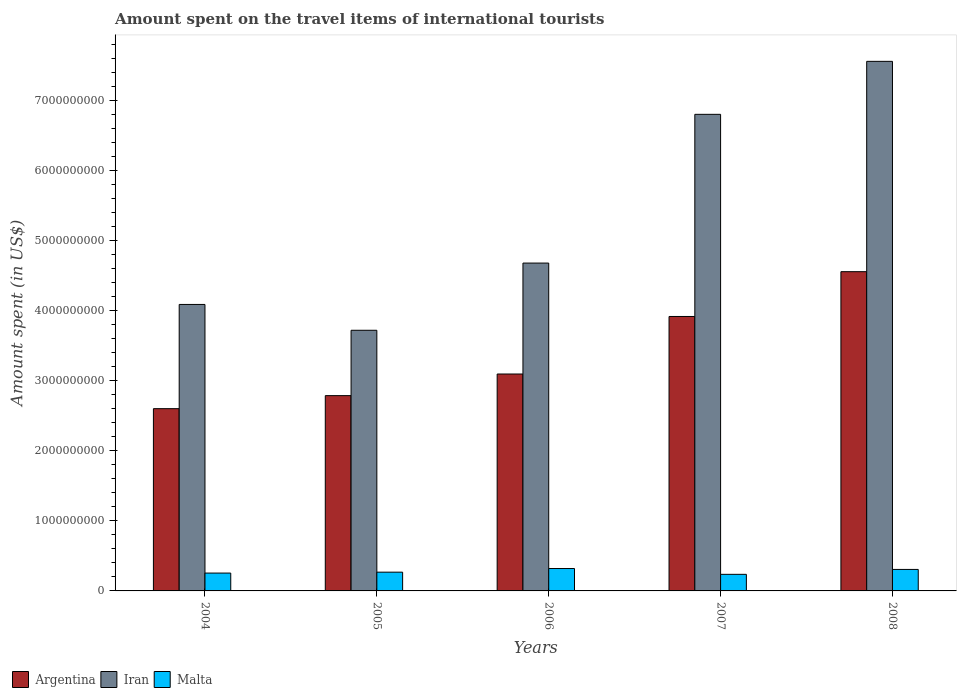Are the number of bars per tick equal to the number of legend labels?
Your answer should be very brief. Yes. How many bars are there on the 1st tick from the left?
Ensure brevity in your answer.  3. How many bars are there on the 2nd tick from the right?
Provide a succinct answer. 3. In how many cases, is the number of bars for a given year not equal to the number of legend labels?
Keep it short and to the point. 0. What is the amount spent on the travel items of international tourists in Argentina in 2005?
Make the answer very short. 2.79e+09. Across all years, what is the maximum amount spent on the travel items of international tourists in Iran?
Your answer should be compact. 7.57e+09. Across all years, what is the minimum amount spent on the travel items of international tourists in Malta?
Give a very brief answer. 2.37e+08. What is the total amount spent on the travel items of international tourists in Malta in the graph?
Your answer should be compact. 1.39e+09. What is the difference between the amount spent on the travel items of international tourists in Malta in 2005 and that in 2006?
Provide a succinct answer. -5.20e+07. What is the difference between the amount spent on the travel items of international tourists in Argentina in 2005 and the amount spent on the travel items of international tourists in Iran in 2006?
Offer a terse response. -1.89e+09. What is the average amount spent on the travel items of international tourists in Malta per year?
Your response must be concise. 2.77e+08. In the year 2005, what is the difference between the amount spent on the travel items of international tourists in Iran and amount spent on the travel items of international tourists in Argentina?
Your answer should be very brief. 9.34e+08. What is the ratio of the amount spent on the travel items of international tourists in Argentina in 2005 to that in 2008?
Give a very brief answer. 0.61. Is the difference between the amount spent on the travel items of international tourists in Iran in 2006 and 2007 greater than the difference between the amount spent on the travel items of international tourists in Argentina in 2006 and 2007?
Offer a very short reply. No. What is the difference between the highest and the second highest amount spent on the travel items of international tourists in Argentina?
Give a very brief answer. 6.40e+08. What is the difference between the highest and the lowest amount spent on the travel items of international tourists in Argentina?
Make the answer very short. 1.96e+09. Is the sum of the amount spent on the travel items of international tourists in Iran in 2007 and 2008 greater than the maximum amount spent on the travel items of international tourists in Malta across all years?
Make the answer very short. Yes. What does the 2nd bar from the left in 2004 represents?
Offer a terse response. Iran. What does the 3rd bar from the right in 2008 represents?
Your answer should be compact. Argentina. How many bars are there?
Your response must be concise. 15. Are all the bars in the graph horizontal?
Your answer should be very brief. No. What is the difference between two consecutive major ticks on the Y-axis?
Your response must be concise. 1.00e+09. Are the values on the major ticks of Y-axis written in scientific E-notation?
Keep it short and to the point. No. Does the graph contain any zero values?
Ensure brevity in your answer.  No. Does the graph contain grids?
Your answer should be very brief. No. How many legend labels are there?
Your response must be concise. 3. How are the legend labels stacked?
Your answer should be very brief. Horizontal. What is the title of the graph?
Offer a terse response. Amount spent on the travel items of international tourists. Does "Syrian Arab Republic" appear as one of the legend labels in the graph?
Offer a terse response. No. What is the label or title of the Y-axis?
Your answer should be very brief. Amount spent (in US$). What is the Amount spent (in US$) of Argentina in 2004?
Provide a succinct answer. 2.60e+09. What is the Amount spent (in US$) of Iran in 2004?
Provide a succinct answer. 4.09e+09. What is the Amount spent (in US$) of Malta in 2004?
Make the answer very short. 2.55e+08. What is the Amount spent (in US$) in Argentina in 2005?
Offer a very short reply. 2.79e+09. What is the Amount spent (in US$) in Iran in 2005?
Provide a succinct answer. 3.72e+09. What is the Amount spent (in US$) in Malta in 2005?
Your response must be concise. 2.68e+08. What is the Amount spent (in US$) of Argentina in 2006?
Give a very brief answer. 3.10e+09. What is the Amount spent (in US$) in Iran in 2006?
Provide a short and direct response. 4.68e+09. What is the Amount spent (in US$) in Malta in 2006?
Give a very brief answer. 3.20e+08. What is the Amount spent (in US$) in Argentina in 2007?
Your response must be concise. 3.92e+09. What is the Amount spent (in US$) of Iran in 2007?
Give a very brief answer. 6.81e+09. What is the Amount spent (in US$) in Malta in 2007?
Provide a short and direct response. 2.37e+08. What is the Amount spent (in US$) of Argentina in 2008?
Your answer should be very brief. 4.56e+09. What is the Amount spent (in US$) in Iran in 2008?
Provide a succinct answer. 7.57e+09. What is the Amount spent (in US$) of Malta in 2008?
Offer a terse response. 3.07e+08. Across all years, what is the maximum Amount spent (in US$) in Argentina?
Give a very brief answer. 4.56e+09. Across all years, what is the maximum Amount spent (in US$) in Iran?
Keep it short and to the point. 7.57e+09. Across all years, what is the maximum Amount spent (in US$) in Malta?
Give a very brief answer. 3.20e+08. Across all years, what is the minimum Amount spent (in US$) in Argentina?
Keep it short and to the point. 2.60e+09. Across all years, what is the minimum Amount spent (in US$) in Iran?
Provide a short and direct response. 3.72e+09. Across all years, what is the minimum Amount spent (in US$) of Malta?
Offer a terse response. 2.37e+08. What is the total Amount spent (in US$) in Argentina in the graph?
Your response must be concise. 1.70e+1. What is the total Amount spent (in US$) of Iran in the graph?
Make the answer very short. 2.69e+1. What is the total Amount spent (in US$) in Malta in the graph?
Offer a very short reply. 1.39e+09. What is the difference between the Amount spent (in US$) in Argentina in 2004 and that in 2005?
Provide a succinct answer. -1.86e+08. What is the difference between the Amount spent (in US$) of Iran in 2004 and that in 2005?
Your answer should be very brief. 3.69e+08. What is the difference between the Amount spent (in US$) of Malta in 2004 and that in 2005?
Your response must be concise. -1.30e+07. What is the difference between the Amount spent (in US$) in Argentina in 2004 and that in 2006?
Provide a succinct answer. -4.95e+08. What is the difference between the Amount spent (in US$) in Iran in 2004 and that in 2006?
Provide a succinct answer. -5.91e+08. What is the difference between the Amount spent (in US$) of Malta in 2004 and that in 2006?
Give a very brief answer. -6.50e+07. What is the difference between the Amount spent (in US$) of Argentina in 2004 and that in 2007?
Give a very brief answer. -1.32e+09. What is the difference between the Amount spent (in US$) in Iran in 2004 and that in 2007?
Your answer should be compact. -2.72e+09. What is the difference between the Amount spent (in US$) in Malta in 2004 and that in 2007?
Make the answer very short. 1.80e+07. What is the difference between the Amount spent (in US$) of Argentina in 2004 and that in 2008?
Your answer should be compact. -1.96e+09. What is the difference between the Amount spent (in US$) in Iran in 2004 and that in 2008?
Offer a terse response. -3.47e+09. What is the difference between the Amount spent (in US$) in Malta in 2004 and that in 2008?
Your answer should be very brief. -5.20e+07. What is the difference between the Amount spent (in US$) in Argentina in 2005 and that in 2006?
Offer a terse response. -3.09e+08. What is the difference between the Amount spent (in US$) of Iran in 2005 and that in 2006?
Your response must be concise. -9.60e+08. What is the difference between the Amount spent (in US$) of Malta in 2005 and that in 2006?
Offer a very short reply. -5.20e+07. What is the difference between the Amount spent (in US$) in Argentina in 2005 and that in 2007?
Ensure brevity in your answer.  -1.13e+09. What is the difference between the Amount spent (in US$) in Iran in 2005 and that in 2007?
Offer a terse response. -3.08e+09. What is the difference between the Amount spent (in US$) in Malta in 2005 and that in 2007?
Keep it short and to the point. 3.10e+07. What is the difference between the Amount spent (in US$) of Argentina in 2005 and that in 2008?
Provide a succinct answer. -1.77e+09. What is the difference between the Amount spent (in US$) of Iran in 2005 and that in 2008?
Provide a succinct answer. -3.84e+09. What is the difference between the Amount spent (in US$) in Malta in 2005 and that in 2008?
Provide a succinct answer. -3.90e+07. What is the difference between the Amount spent (in US$) in Argentina in 2006 and that in 2007?
Give a very brief answer. -8.22e+08. What is the difference between the Amount spent (in US$) in Iran in 2006 and that in 2007?
Offer a terse response. -2.12e+09. What is the difference between the Amount spent (in US$) in Malta in 2006 and that in 2007?
Your response must be concise. 8.30e+07. What is the difference between the Amount spent (in US$) of Argentina in 2006 and that in 2008?
Provide a succinct answer. -1.46e+09. What is the difference between the Amount spent (in US$) in Iran in 2006 and that in 2008?
Provide a succinct answer. -2.88e+09. What is the difference between the Amount spent (in US$) of Malta in 2006 and that in 2008?
Your response must be concise. 1.30e+07. What is the difference between the Amount spent (in US$) in Argentina in 2007 and that in 2008?
Offer a very short reply. -6.40e+08. What is the difference between the Amount spent (in US$) in Iran in 2007 and that in 2008?
Ensure brevity in your answer.  -7.57e+08. What is the difference between the Amount spent (in US$) in Malta in 2007 and that in 2008?
Your answer should be very brief. -7.00e+07. What is the difference between the Amount spent (in US$) in Argentina in 2004 and the Amount spent (in US$) in Iran in 2005?
Make the answer very short. -1.12e+09. What is the difference between the Amount spent (in US$) of Argentina in 2004 and the Amount spent (in US$) of Malta in 2005?
Provide a short and direct response. 2.34e+09. What is the difference between the Amount spent (in US$) of Iran in 2004 and the Amount spent (in US$) of Malta in 2005?
Your answer should be compact. 3.82e+09. What is the difference between the Amount spent (in US$) of Argentina in 2004 and the Amount spent (in US$) of Iran in 2006?
Your answer should be very brief. -2.08e+09. What is the difference between the Amount spent (in US$) in Argentina in 2004 and the Amount spent (in US$) in Malta in 2006?
Offer a very short reply. 2.28e+09. What is the difference between the Amount spent (in US$) of Iran in 2004 and the Amount spent (in US$) of Malta in 2006?
Give a very brief answer. 3.77e+09. What is the difference between the Amount spent (in US$) in Argentina in 2004 and the Amount spent (in US$) in Iran in 2007?
Provide a succinct answer. -4.20e+09. What is the difference between the Amount spent (in US$) in Argentina in 2004 and the Amount spent (in US$) in Malta in 2007?
Give a very brief answer. 2.37e+09. What is the difference between the Amount spent (in US$) in Iran in 2004 and the Amount spent (in US$) in Malta in 2007?
Your response must be concise. 3.86e+09. What is the difference between the Amount spent (in US$) of Argentina in 2004 and the Amount spent (in US$) of Iran in 2008?
Give a very brief answer. -4.96e+09. What is the difference between the Amount spent (in US$) in Argentina in 2004 and the Amount spent (in US$) in Malta in 2008?
Make the answer very short. 2.30e+09. What is the difference between the Amount spent (in US$) of Iran in 2004 and the Amount spent (in US$) of Malta in 2008?
Make the answer very short. 3.79e+09. What is the difference between the Amount spent (in US$) in Argentina in 2005 and the Amount spent (in US$) in Iran in 2006?
Ensure brevity in your answer.  -1.89e+09. What is the difference between the Amount spent (in US$) in Argentina in 2005 and the Amount spent (in US$) in Malta in 2006?
Your answer should be compact. 2.47e+09. What is the difference between the Amount spent (in US$) of Iran in 2005 and the Amount spent (in US$) of Malta in 2006?
Ensure brevity in your answer.  3.40e+09. What is the difference between the Amount spent (in US$) in Argentina in 2005 and the Amount spent (in US$) in Iran in 2007?
Offer a very short reply. -4.02e+09. What is the difference between the Amount spent (in US$) in Argentina in 2005 and the Amount spent (in US$) in Malta in 2007?
Give a very brief answer. 2.55e+09. What is the difference between the Amount spent (in US$) in Iran in 2005 and the Amount spent (in US$) in Malta in 2007?
Provide a short and direct response. 3.49e+09. What is the difference between the Amount spent (in US$) of Argentina in 2005 and the Amount spent (in US$) of Iran in 2008?
Your answer should be compact. -4.78e+09. What is the difference between the Amount spent (in US$) in Argentina in 2005 and the Amount spent (in US$) in Malta in 2008?
Make the answer very short. 2.48e+09. What is the difference between the Amount spent (in US$) of Iran in 2005 and the Amount spent (in US$) of Malta in 2008?
Provide a succinct answer. 3.42e+09. What is the difference between the Amount spent (in US$) of Argentina in 2006 and the Amount spent (in US$) of Iran in 2007?
Your response must be concise. -3.71e+09. What is the difference between the Amount spent (in US$) of Argentina in 2006 and the Amount spent (in US$) of Malta in 2007?
Provide a short and direct response. 2.86e+09. What is the difference between the Amount spent (in US$) in Iran in 2006 and the Amount spent (in US$) in Malta in 2007?
Your answer should be very brief. 4.45e+09. What is the difference between the Amount spent (in US$) of Argentina in 2006 and the Amount spent (in US$) of Iran in 2008?
Ensure brevity in your answer.  -4.47e+09. What is the difference between the Amount spent (in US$) in Argentina in 2006 and the Amount spent (in US$) in Malta in 2008?
Provide a short and direct response. 2.79e+09. What is the difference between the Amount spent (in US$) of Iran in 2006 and the Amount spent (in US$) of Malta in 2008?
Give a very brief answer. 4.38e+09. What is the difference between the Amount spent (in US$) of Argentina in 2007 and the Amount spent (in US$) of Iran in 2008?
Make the answer very short. -3.64e+09. What is the difference between the Amount spent (in US$) in Argentina in 2007 and the Amount spent (in US$) in Malta in 2008?
Provide a short and direct response. 3.61e+09. What is the difference between the Amount spent (in US$) of Iran in 2007 and the Amount spent (in US$) of Malta in 2008?
Make the answer very short. 6.50e+09. What is the average Amount spent (in US$) in Argentina per year?
Keep it short and to the point. 3.40e+09. What is the average Amount spent (in US$) in Iran per year?
Your response must be concise. 5.38e+09. What is the average Amount spent (in US$) of Malta per year?
Make the answer very short. 2.77e+08. In the year 2004, what is the difference between the Amount spent (in US$) in Argentina and Amount spent (in US$) in Iran?
Make the answer very short. -1.49e+09. In the year 2004, what is the difference between the Amount spent (in US$) of Argentina and Amount spent (in US$) of Malta?
Your answer should be compact. 2.35e+09. In the year 2004, what is the difference between the Amount spent (in US$) in Iran and Amount spent (in US$) in Malta?
Your answer should be compact. 3.84e+09. In the year 2005, what is the difference between the Amount spent (in US$) of Argentina and Amount spent (in US$) of Iran?
Offer a terse response. -9.34e+08. In the year 2005, what is the difference between the Amount spent (in US$) of Argentina and Amount spent (in US$) of Malta?
Make the answer very short. 2.52e+09. In the year 2005, what is the difference between the Amount spent (in US$) of Iran and Amount spent (in US$) of Malta?
Keep it short and to the point. 3.46e+09. In the year 2006, what is the difference between the Amount spent (in US$) in Argentina and Amount spent (in US$) in Iran?
Keep it short and to the point. -1.58e+09. In the year 2006, what is the difference between the Amount spent (in US$) of Argentina and Amount spent (in US$) of Malta?
Provide a short and direct response. 2.78e+09. In the year 2006, what is the difference between the Amount spent (in US$) of Iran and Amount spent (in US$) of Malta?
Ensure brevity in your answer.  4.36e+09. In the year 2007, what is the difference between the Amount spent (in US$) of Argentina and Amount spent (in US$) of Iran?
Offer a terse response. -2.89e+09. In the year 2007, what is the difference between the Amount spent (in US$) of Argentina and Amount spent (in US$) of Malta?
Provide a short and direct response. 3.68e+09. In the year 2007, what is the difference between the Amount spent (in US$) of Iran and Amount spent (in US$) of Malta?
Provide a succinct answer. 6.57e+09. In the year 2008, what is the difference between the Amount spent (in US$) in Argentina and Amount spent (in US$) in Iran?
Give a very brief answer. -3.00e+09. In the year 2008, what is the difference between the Amount spent (in US$) of Argentina and Amount spent (in US$) of Malta?
Ensure brevity in your answer.  4.25e+09. In the year 2008, what is the difference between the Amount spent (in US$) of Iran and Amount spent (in US$) of Malta?
Keep it short and to the point. 7.26e+09. What is the ratio of the Amount spent (in US$) of Argentina in 2004 to that in 2005?
Make the answer very short. 0.93. What is the ratio of the Amount spent (in US$) of Iran in 2004 to that in 2005?
Your answer should be very brief. 1.1. What is the ratio of the Amount spent (in US$) of Malta in 2004 to that in 2005?
Ensure brevity in your answer.  0.95. What is the ratio of the Amount spent (in US$) in Argentina in 2004 to that in 2006?
Ensure brevity in your answer.  0.84. What is the ratio of the Amount spent (in US$) of Iran in 2004 to that in 2006?
Ensure brevity in your answer.  0.87. What is the ratio of the Amount spent (in US$) in Malta in 2004 to that in 2006?
Your response must be concise. 0.8. What is the ratio of the Amount spent (in US$) in Argentina in 2004 to that in 2007?
Provide a succinct answer. 0.66. What is the ratio of the Amount spent (in US$) of Iran in 2004 to that in 2007?
Provide a succinct answer. 0.6. What is the ratio of the Amount spent (in US$) in Malta in 2004 to that in 2007?
Your answer should be compact. 1.08. What is the ratio of the Amount spent (in US$) in Argentina in 2004 to that in 2008?
Make the answer very short. 0.57. What is the ratio of the Amount spent (in US$) of Iran in 2004 to that in 2008?
Offer a very short reply. 0.54. What is the ratio of the Amount spent (in US$) of Malta in 2004 to that in 2008?
Keep it short and to the point. 0.83. What is the ratio of the Amount spent (in US$) of Argentina in 2005 to that in 2006?
Your answer should be compact. 0.9. What is the ratio of the Amount spent (in US$) in Iran in 2005 to that in 2006?
Offer a terse response. 0.8. What is the ratio of the Amount spent (in US$) of Malta in 2005 to that in 2006?
Provide a succinct answer. 0.84. What is the ratio of the Amount spent (in US$) of Argentina in 2005 to that in 2007?
Provide a short and direct response. 0.71. What is the ratio of the Amount spent (in US$) of Iran in 2005 to that in 2007?
Make the answer very short. 0.55. What is the ratio of the Amount spent (in US$) in Malta in 2005 to that in 2007?
Offer a very short reply. 1.13. What is the ratio of the Amount spent (in US$) of Argentina in 2005 to that in 2008?
Provide a short and direct response. 0.61. What is the ratio of the Amount spent (in US$) in Iran in 2005 to that in 2008?
Your answer should be compact. 0.49. What is the ratio of the Amount spent (in US$) in Malta in 2005 to that in 2008?
Your answer should be compact. 0.87. What is the ratio of the Amount spent (in US$) of Argentina in 2006 to that in 2007?
Ensure brevity in your answer.  0.79. What is the ratio of the Amount spent (in US$) in Iran in 2006 to that in 2007?
Keep it short and to the point. 0.69. What is the ratio of the Amount spent (in US$) in Malta in 2006 to that in 2007?
Your response must be concise. 1.35. What is the ratio of the Amount spent (in US$) of Argentina in 2006 to that in 2008?
Provide a short and direct response. 0.68. What is the ratio of the Amount spent (in US$) of Iran in 2006 to that in 2008?
Your answer should be very brief. 0.62. What is the ratio of the Amount spent (in US$) of Malta in 2006 to that in 2008?
Offer a terse response. 1.04. What is the ratio of the Amount spent (in US$) of Argentina in 2007 to that in 2008?
Ensure brevity in your answer.  0.86. What is the ratio of the Amount spent (in US$) of Iran in 2007 to that in 2008?
Your response must be concise. 0.9. What is the ratio of the Amount spent (in US$) in Malta in 2007 to that in 2008?
Offer a very short reply. 0.77. What is the difference between the highest and the second highest Amount spent (in US$) of Argentina?
Ensure brevity in your answer.  6.40e+08. What is the difference between the highest and the second highest Amount spent (in US$) of Iran?
Offer a very short reply. 7.57e+08. What is the difference between the highest and the second highest Amount spent (in US$) in Malta?
Your answer should be compact. 1.30e+07. What is the difference between the highest and the lowest Amount spent (in US$) in Argentina?
Your response must be concise. 1.96e+09. What is the difference between the highest and the lowest Amount spent (in US$) of Iran?
Ensure brevity in your answer.  3.84e+09. What is the difference between the highest and the lowest Amount spent (in US$) in Malta?
Your answer should be very brief. 8.30e+07. 